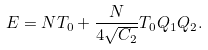Convert formula to latex. <formula><loc_0><loc_0><loc_500><loc_500>E = N T _ { 0 } + \frac { N } { 4 \sqrt { C _ { 2 } } } T _ { 0 } Q _ { 1 } Q _ { 2 } .</formula> 